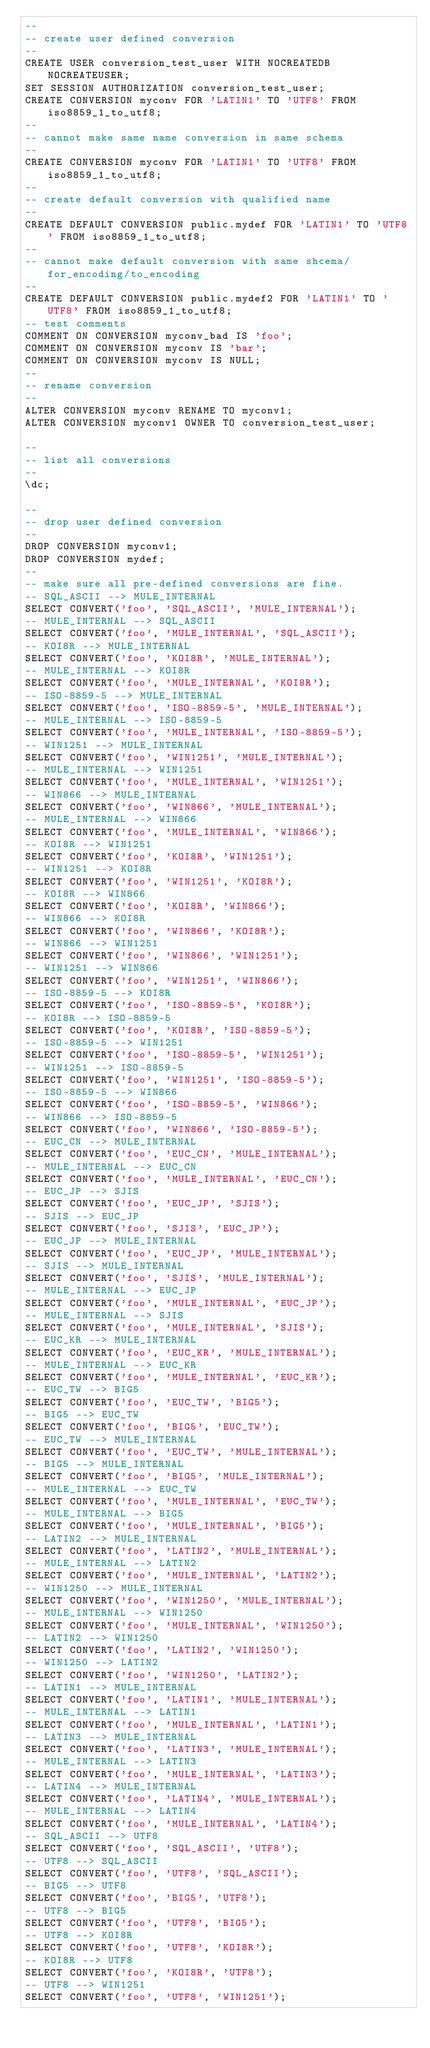<code> <loc_0><loc_0><loc_500><loc_500><_SQL_>--
-- create user defined conversion
--
CREATE USER conversion_test_user WITH NOCREATEDB NOCREATEUSER;
SET SESSION AUTHORIZATION conversion_test_user;
CREATE CONVERSION myconv FOR 'LATIN1' TO 'UTF8' FROM iso8859_1_to_utf8;
--
-- cannot make same name conversion in same schema
--
CREATE CONVERSION myconv FOR 'LATIN1' TO 'UTF8' FROM iso8859_1_to_utf8;
--
-- create default conversion with qualified name
--
CREATE DEFAULT CONVERSION public.mydef FOR 'LATIN1' TO 'UTF8' FROM iso8859_1_to_utf8;
--
-- cannot make default conversion with same shcema/for_encoding/to_encoding
--
CREATE DEFAULT CONVERSION public.mydef2 FOR 'LATIN1' TO 'UTF8' FROM iso8859_1_to_utf8;
-- test comments
COMMENT ON CONVERSION myconv_bad IS 'foo';
COMMENT ON CONVERSION myconv IS 'bar';
COMMENT ON CONVERSION myconv IS NULL;
--
-- rename conversion
--
ALTER CONVERSION myconv RENAME TO myconv1;
ALTER CONVERSION myconv1 OWNER TO conversion_test_user;

-- 
-- list all conversions 
-- 
\dc;

--
-- drop user defined conversion
--
DROP CONVERSION myconv1;
DROP CONVERSION mydef;
--
-- make sure all pre-defined conversions are fine.
-- SQL_ASCII --> MULE_INTERNAL
SELECT CONVERT('foo', 'SQL_ASCII', 'MULE_INTERNAL');
-- MULE_INTERNAL --> SQL_ASCII
SELECT CONVERT('foo', 'MULE_INTERNAL', 'SQL_ASCII');
-- KOI8R --> MULE_INTERNAL
SELECT CONVERT('foo', 'KOI8R', 'MULE_INTERNAL');
-- MULE_INTERNAL --> KOI8R
SELECT CONVERT('foo', 'MULE_INTERNAL', 'KOI8R');
-- ISO-8859-5 --> MULE_INTERNAL
SELECT CONVERT('foo', 'ISO-8859-5', 'MULE_INTERNAL');
-- MULE_INTERNAL --> ISO-8859-5
SELECT CONVERT('foo', 'MULE_INTERNAL', 'ISO-8859-5');
-- WIN1251 --> MULE_INTERNAL
SELECT CONVERT('foo', 'WIN1251', 'MULE_INTERNAL');
-- MULE_INTERNAL --> WIN1251
SELECT CONVERT('foo', 'MULE_INTERNAL', 'WIN1251');
-- WIN866 --> MULE_INTERNAL
SELECT CONVERT('foo', 'WIN866', 'MULE_INTERNAL');
-- MULE_INTERNAL --> WIN866
SELECT CONVERT('foo', 'MULE_INTERNAL', 'WIN866');
-- KOI8R --> WIN1251
SELECT CONVERT('foo', 'KOI8R', 'WIN1251');
-- WIN1251 --> KOI8R
SELECT CONVERT('foo', 'WIN1251', 'KOI8R');
-- KOI8R --> WIN866
SELECT CONVERT('foo', 'KOI8R', 'WIN866');
-- WIN866 --> KOI8R
SELECT CONVERT('foo', 'WIN866', 'KOI8R');
-- WIN866 --> WIN1251
SELECT CONVERT('foo', 'WIN866', 'WIN1251');
-- WIN1251 --> WIN866
SELECT CONVERT('foo', 'WIN1251', 'WIN866');
-- ISO-8859-5 --> KOI8R
SELECT CONVERT('foo', 'ISO-8859-5', 'KOI8R');
-- KOI8R --> ISO-8859-5
SELECT CONVERT('foo', 'KOI8R', 'ISO-8859-5');
-- ISO-8859-5 --> WIN1251
SELECT CONVERT('foo', 'ISO-8859-5', 'WIN1251');
-- WIN1251 --> ISO-8859-5
SELECT CONVERT('foo', 'WIN1251', 'ISO-8859-5');
-- ISO-8859-5 --> WIN866
SELECT CONVERT('foo', 'ISO-8859-5', 'WIN866');
-- WIN866 --> ISO-8859-5
SELECT CONVERT('foo', 'WIN866', 'ISO-8859-5');
-- EUC_CN --> MULE_INTERNAL
SELECT CONVERT('foo', 'EUC_CN', 'MULE_INTERNAL');
-- MULE_INTERNAL --> EUC_CN
SELECT CONVERT('foo', 'MULE_INTERNAL', 'EUC_CN');
-- EUC_JP --> SJIS
SELECT CONVERT('foo', 'EUC_JP', 'SJIS');
-- SJIS --> EUC_JP
SELECT CONVERT('foo', 'SJIS', 'EUC_JP');
-- EUC_JP --> MULE_INTERNAL
SELECT CONVERT('foo', 'EUC_JP', 'MULE_INTERNAL');
-- SJIS --> MULE_INTERNAL
SELECT CONVERT('foo', 'SJIS', 'MULE_INTERNAL');
-- MULE_INTERNAL --> EUC_JP
SELECT CONVERT('foo', 'MULE_INTERNAL', 'EUC_JP');
-- MULE_INTERNAL --> SJIS
SELECT CONVERT('foo', 'MULE_INTERNAL', 'SJIS');
-- EUC_KR --> MULE_INTERNAL
SELECT CONVERT('foo', 'EUC_KR', 'MULE_INTERNAL');
-- MULE_INTERNAL --> EUC_KR
SELECT CONVERT('foo', 'MULE_INTERNAL', 'EUC_KR');
-- EUC_TW --> BIG5
SELECT CONVERT('foo', 'EUC_TW', 'BIG5');
-- BIG5 --> EUC_TW
SELECT CONVERT('foo', 'BIG5', 'EUC_TW');
-- EUC_TW --> MULE_INTERNAL
SELECT CONVERT('foo', 'EUC_TW', 'MULE_INTERNAL');
-- BIG5 --> MULE_INTERNAL
SELECT CONVERT('foo', 'BIG5', 'MULE_INTERNAL');
-- MULE_INTERNAL --> EUC_TW
SELECT CONVERT('foo', 'MULE_INTERNAL', 'EUC_TW');
-- MULE_INTERNAL --> BIG5
SELECT CONVERT('foo', 'MULE_INTERNAL', 'BIG5');
-- LATIN2 --> MULE_INTERNAL
SELECT CONVERT('foo', 'LATIN2', 'MULE_INTERNAL');
-- MULE_INTERNAL --> LATIN2
SELECT CONVERT('foo', 'MULE_INTERNAL', 'LATIN2');
-- WIN1250 --> MULE_INTERNAL
SELECT CONVERT('foo', 'WIN1250', 'MULE_INTERNAL');
-- MULE_INTERNAL --> WIN1250
SELECT CONVERT('foo', 'MULE_INTERNAL', 'WIN1250');
-- LATIN2 --> WIN1250
SELECT CONVERT('foo', 'LATIN2', 'WIN1250');
-- WIN1250 --> LATIN2
SELECT CONVERT('foo', 'WIN1250', 'LATIN2');
-- LATIN1 --> MULE_INTERNAL
SELECT CONVERT('foo', 'LATIN1', 'MULE_INTERNAL');
-- MULE_INTERNAL --> LATIN1
SELECT CONVERT('foo', 'MULE_INTERNAL', 'LATIN1');
-- LATIN3 --> MULE_INTERNAL
SELECT CONVERT('foo', 'LATIN3', 'MULE_INTERNAL');
-- MULE_INTERNAL --> LATIN3
SELECT CONVERT('foo', 'MULE_INTERNAL', 'LATIN3');
-- LATIN4 --> MULE_INTERNAL
SELECT CONVERT('foo', 'LATIN4', 'MULE_INTERNAL');
-- MULE_INTERNAL --> LATIN4
SELECT CONVERT('foo', 'MULE_INTERNAL', 'LATIN4');
-- SQL_ASCII --> UTF8
SELECT CONVERT('foo', 'SQL_ASCII', 'UTF8');
-- UTF8 --> SQL_ASCII
SELECT CONVERT('foo', 'UTF8', 'SQL_ASCII');
-- BIG5 --> UTF8
SELECT CONVERT('foo', 'BIG5', 'UTF8');
-- UTF8 --> BIG5
SELECT CONVERT('foo', 'UTF8', 'BIG5');
-- UTF8 --> KOI8R
SELECT CONVERT('foo', 'UTF8', 'KOI8R');
-- KOI8R --> UTF8
SELECT CONVERT('foo', 'KOI8R', 'UTF8');
-- UTF8 --> WIN1251
SELECT CONVERT('foo', 'UTF8', 'WIN1251');</code> 